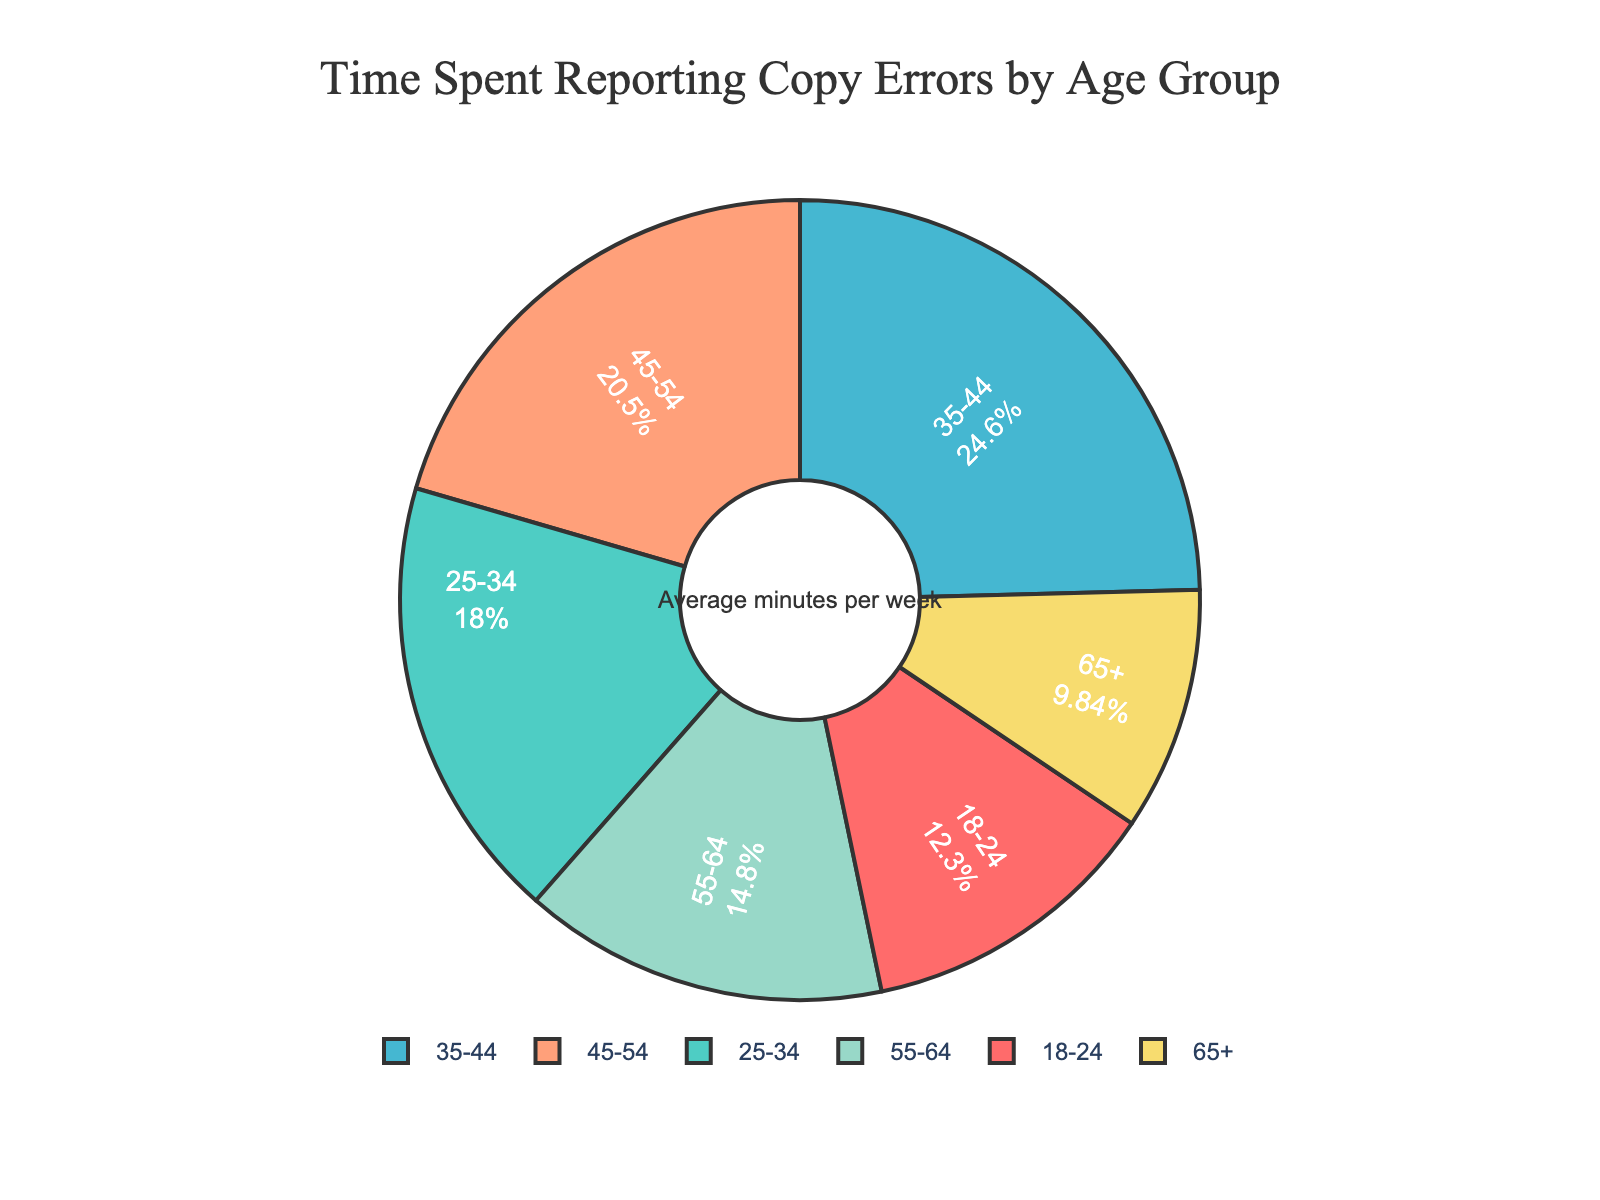what age group spends the most time reporting copy errors? The 35-44 age group spends the most time reporting copy errors. Visually, this is shown by the largest slice of the pie chart with the highest time of 30 minutes per week.
Answer: 35-44 which age group spends less time than the 25-34 group but more than the 18-24 group? By looking at the pie chart, the 45-54 age group spends 25 minutes, which is more than the 18-24 group (15 minutes) but less than the 25-34 group (22 minutes).
Answer: 45-54 how much time difference is there between the youngest and the oldest age groups? The 18-24 age group spends 15 minutes, while the 65+ age group spends 12 minutes. The difference is 15 - 12 = 3 minutes.
Answer: 3 minutes which two age groups together account for more than 50% of the total time spent? The 35-44 group spends 30% and the 45-54 group spends 25%, together they account for 55% (30% + 25%), which is more than 50%.
Answer: 35-44 and 45-54 if the total time spent per week by all age groups is 122 minutes, what is the combined time spent by the 18-24 and 65+ age groups? The 18-24 group spends 15 minutes, and the 65+ group spends 12 minutes. Combined: 15 + 12 = 27 minutes.
Answer: 27 minutes what percentage of time does the 55-64 age group contribute to reporting copy errors? The 55-64 age group spends 18 minutes. The pie chart also shows percentages, with this group contributing approximately 15% of the overall time.
Answer: 15% how does the time spent by the 25-34 age group compare visually to the 18-24 age group? Visually, the slice representing the 25-34 age group is larger than the 18-24 age group, indicating that they spend more time reporting errors. The 25-34 group spends 22 minutes, while the 18-24 group spends 15 minutes.
Answer: 25-34 spends more what is the average time spent across all age groups? The sum of time spent is 15 + 22 + 30 + 25 + 18 + 12 = 122 minutes. There are 6 age groups, so the average time spent is 122 / 6 = 20.33 minutes per week.
Answer: 20.33 minutes how much more time does the 45-54 group spend compared to the 55-64 group? The 45-54 group spends 25 minutes and the 55-64 group spends 18 minutes. The 45-54 group spends 25 - 18 = 7 minutes more.
Answer: 7 minutes which age group's contribution is represented by a green slice in the pie chart? The 25-34 age group's contribution is represented by the green slice in the pie chart.
Answer: 25-34 